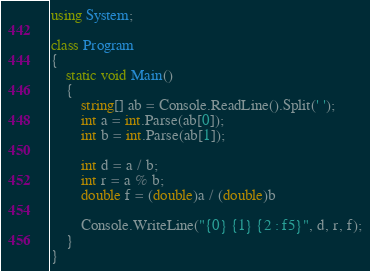<code> <loc_0><loc_0><loc_500><loc_500><_C#_>using System;

class Program
{
    static void Main()
    {
        string[] ab = Console.ReadLine().Split(' ');
        int a = int.Parse(ab[0]);
        int b = int.Parse(ab[1]);

        int d = a / b;
        int r = a % b;
        double f = (double)a / (double)b

        Console.WriteLine("{0} {1} {2 : f5}", d, r, f);
    }
}</code> 